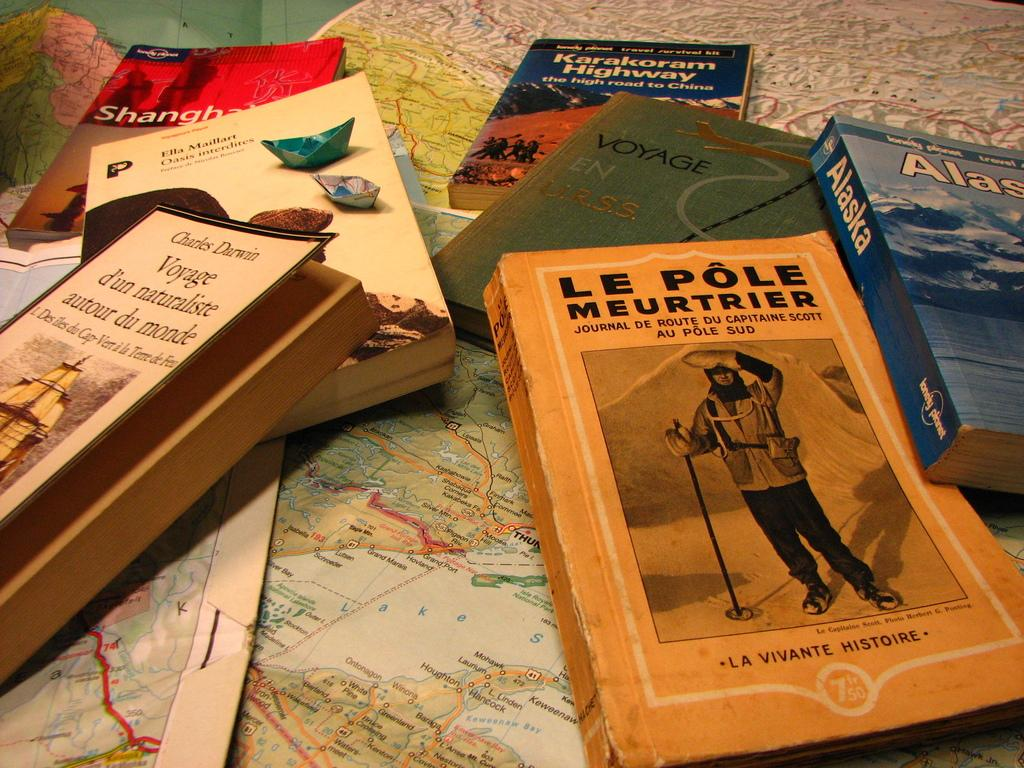<image>
Create a compact narrative representing the image presented. A small pile of travel books which include one on Alaska over a map 